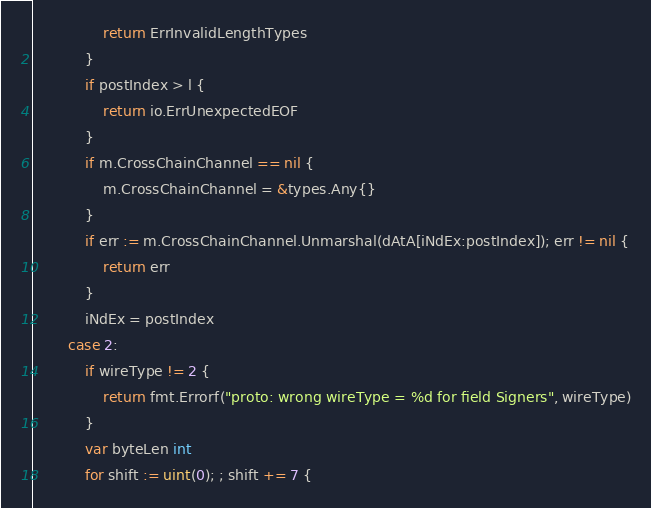<code> <loc_0><loc_0><loc_500><loc_500><_Go_>				return ErrInvalidLengthTypes
			}
			if postIndex > l {
				return io.ErrUnexpectedEOF
			}
			if m.CrossChainChannel == nil {
				m.CrossChainChannel = &types.Any{}
			}
			if err := m.CrossChainChannel.Unmarshal(dAtA[iNdEx:postIndex]); err != nil {
				return err
			}
			iNdEx = postIndex
		case 2:
			if wireType != 2 {
				return fmt.Errorf("proto: wrong wireType = %d for field Signers", wireType)
			}
			var byteLen int
			for shift := uint(0); ; shift += 7 {</code> 